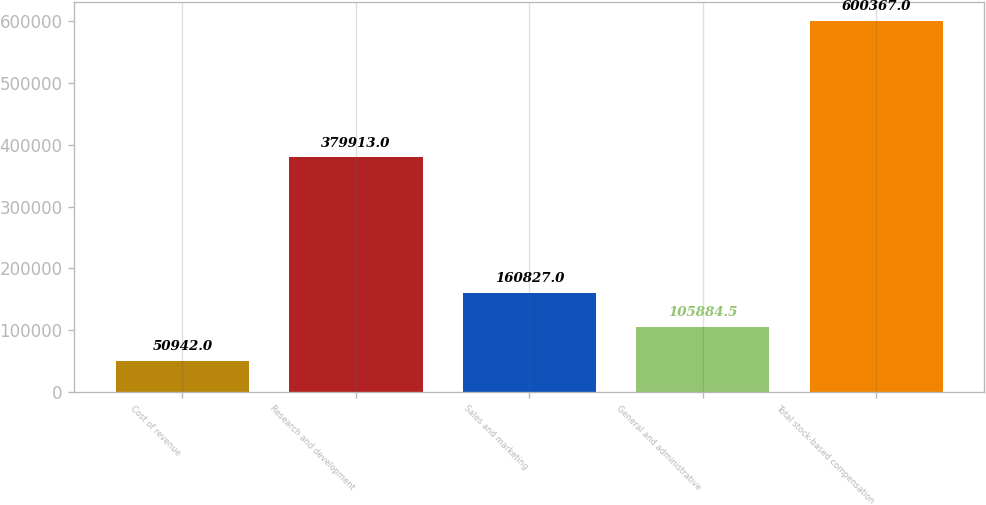Convert chart. <chart><loc_0><loc_0><loc_500><loc_500><bar_chart><fcel>Cost of revenue<fcel>Research and development<fcel>Sales and marketing<fcel>General and administrative<fcel>Total stock-based compensation<nl><fcel>50942<fcel>379913<fcel>160827<fcel>105884<fcel>600367<nl></chart> 